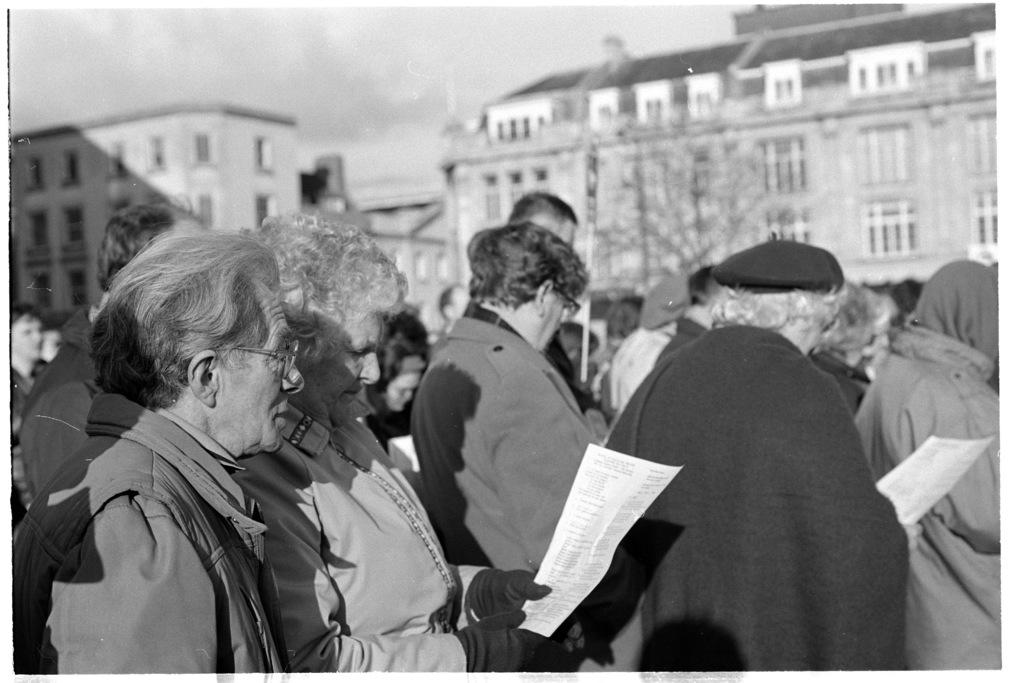What are the people in the image doing? The people are standing in the image and holding a paper with written text on it. What can be seen in the background of the image? There are buildings visible in the background, and they have windows. What is visible at the top of the image? The sky is visible at the top of the image. What type of sponge can be seen in the image? There is no sponge present in the image. How does the anger of the people in the image affect the buildings in the background? There is no indication of anger in the image, and therefore it cannot be determined how it would affect the buildings. 